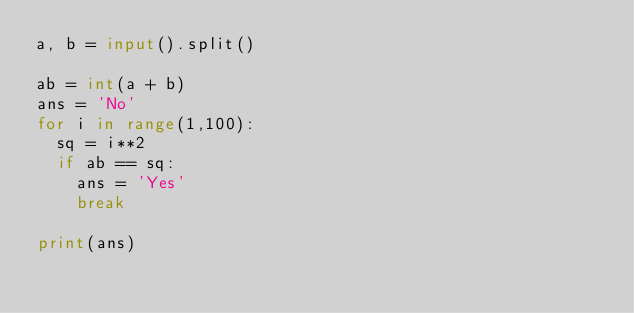Convert code to text. <code><loc_0><loc_0><loc_500><loc_500><_Python_>a, b = input().split()

ab = int(a + b)
ans = 'No'
for i in range(1,100):
  sq = i**2
  if ab == sq:
    ans = 'Yes'
    break

print(ans)
</code> 